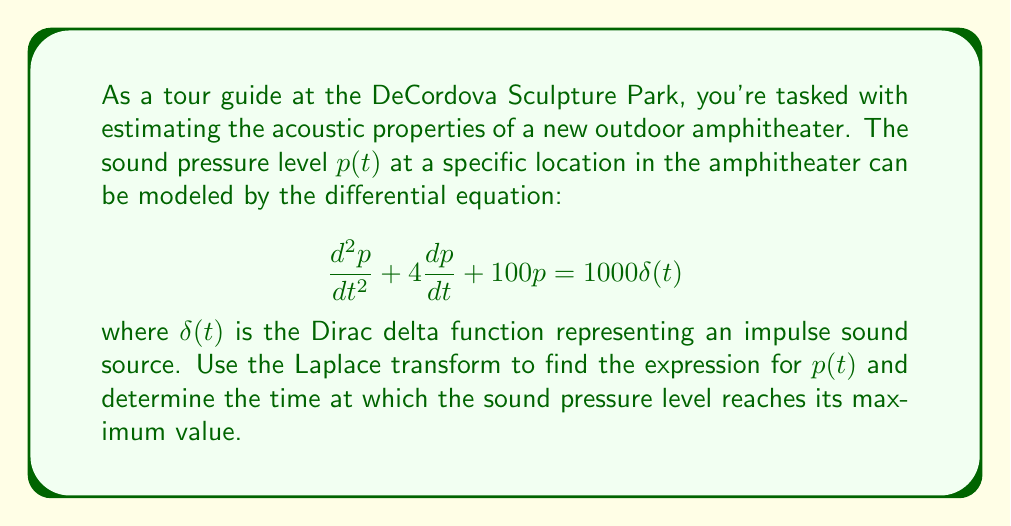Can you solve this math problem? Let's solve this problem step by step using the Laplace transform:

1) First, we take the Laplace transform of both sides of the equation. Let $P(s) = \mathcal{L}\{p(t)\}$.

   $$\mathcal{L}\{\frac{d^2p}{dt^2} + 4\frac{dp}{dt} + 100p\} = \mathcal{L}\{1000\delta(t)\}$$

2) Using Laplace transform properties:

   $$s^2P(s) - sp(0) - p'(0) + 4[sP(s) - p(0)] + 100P(s) = 1000$$

3) Assuming initial conditions $p(0) = 0$ and $p'(0) = 0$:

   $$s^2P(s) + 4sP(s) + 100P(s) = 1000$$
   $$(s^2 + 4s + 100)P(s) = 1000$$

4) Solving for $P(s)$:

   $$P(s) = \frac{1000}{s^2 + 4s + 100} = \frac{1000}{(s+2)^2 + 96}$$

5) To find the inverse Laplace transform, we can use the second shift theorem:

   $$p(t) = \frac{1000}{\sqrt{96}}e^{-2t}\sin(\sqrt{96}t)$$

6) To find the maximum value, we differentiate $p(t)$ and set it to zero:

   $$\frac{dp}{dt} = \frac{1000}{\sqrt{96}}e^{-2t}[-2\sin(\sqrt{96}t) + \sqrt{96}\cos(\sqrt{96}t)] = 0$$

7) This gives us:

   $$\tan(\sqrt{96}t) = \frac{\sqrt{96}}{2}$$

8) Solving this equation:

   $$t = \frac{1}{\sqrt{96}}\arctan(\frac{\sqrt{96}}{2}) \approx 0.2618 \text{ seconds}$$
Answer: The sound pressure level $p(t)$ is given by:

$$p(t) = \frac{1000}{\sqrt{96}}e^{-2t}\sin(\sqrt{96}t)$$

The maximum sound pressure level occurs approximately 0.2618 seconds after the impulse. 